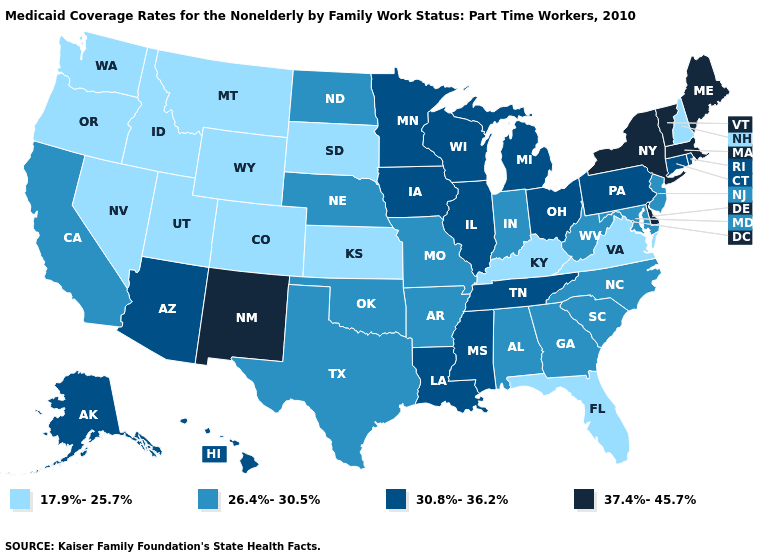Which states hav the highest value in the Northeast?
Give a very brief answer. Maine, Massachusetts, New York, Vermont. Does Iowa have the highest value in the USA?
Quick response, please. No. Name the states that have a value in the range 26.4%-30.5%?
Keep it brief. Alabama, Arkansas, California, Georgia, Indiana, Maryland, Missouri, Nebraska, New Jersey, North Carolina, North Dakota, Oklahoma, South Carolina, Texas, West Virginia. Among the states that border Vermont , which have the highest value?
Short answer required. Massachusetts, New York. What is the lowest value in the Northeast?
Keep it brief. 17.9%-25.7%. Among the states that border Michigan , which have the lowest value?
Be succinct. Indiana. What is the value of Wisconsin?
Be succinct. 30.8%-36.2%. Name the states that have a value in the range 30.8%-36.2%?
Quick response, please. Alaska, Arizona, Connecticut, Hawaii, Illinois, Iowa, Louisiana, Michigan, Minnesota, Mississippi, Ohio, Pennsylvania, Rhode Island, Tennessee, Wisconsin. Among the states that border New York , which have the highest value?
Quick response, please. Massachusetts, Vermont. Does the first symbol in the legend represent the smallest category?
Write a very short answer. Yes. Name the states that have a value in the range 26.4%-30.5%?
Give a very brief answer. Alabama, Arkansas, California, Georgia, Indiana, Maryland, Missouri, Nebraska, New Jersey, North Carolina, North Dakota, Oklahoma, South Carolina, Texas, West Virginia. Name the states that have a value in the range 26.4%-30.5%?
Give a very brief answer. Alabama, Arkansas, California, Georgia, Indiana, Maryland, Missouri, Nebraska, New Jersey, North Carolina, North Dakota, Oklahoma, South Carolina, Texas, West Virginia. Name the states that have a value in the range 37.4%-45.7%?
Short answer required. Delaware, Maine, Massachusetts, New Mexico, New York, Vermont. What is the value of Maryland?
Concise answer only. 26.4%-30.5%. What is the value of Arkansas?
Write a very short answer. 26.4%-30.5%. 